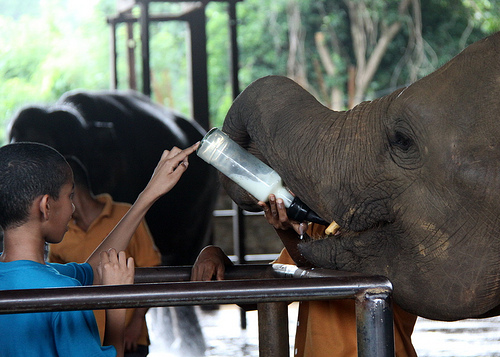<image>
Is the branch above the person? No. The branch is not positioned above the person. The vertical arrangement shows a different relationship. 